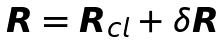<formula> <loc_0><loc_0><loc_500><loc_500>\boldsymbol R = \boldsymbol R _ { c l } + \delta \boldsymbol R</formula> 